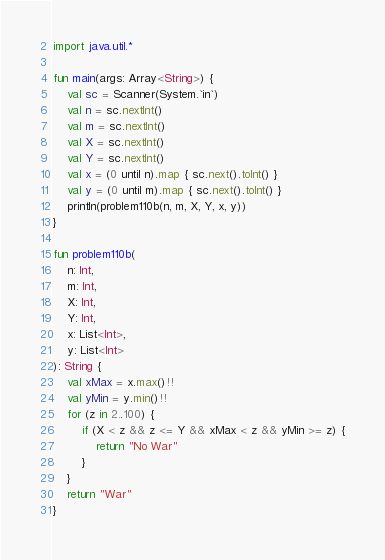<code> <loc_0><loc_0><loc_500><loc_500><_Kotlin_>import java.util.*

fun main(args: Array<String>) {
    val sc = Scanner(System.`in`)
    val n = sc.nextInt()
    val m = sc.nextInt()
    val X = sc.nextInt()
    val Y = sc.nextInt()
    val x = (0 until n).map { sc.next().toInt() }
    val y = (0 until m).map { sc.next().toInt() }
    println(problem110b(n, m, X, Y, x, y))
}

fun problem110b(
    n: Int,
    m: Int,
    X: Int,
    Y: Int,
    x: List<Int>,
    y: List<Int>
): String {
    val xMax = x.max()!!
    val yMin = y.min()!!
    for (z in 2..100) {
        if (X < z && z <= Y && xMax < z && yMin >= z) {
            return "No War"
        }
    }
    return "War"
}</code> 